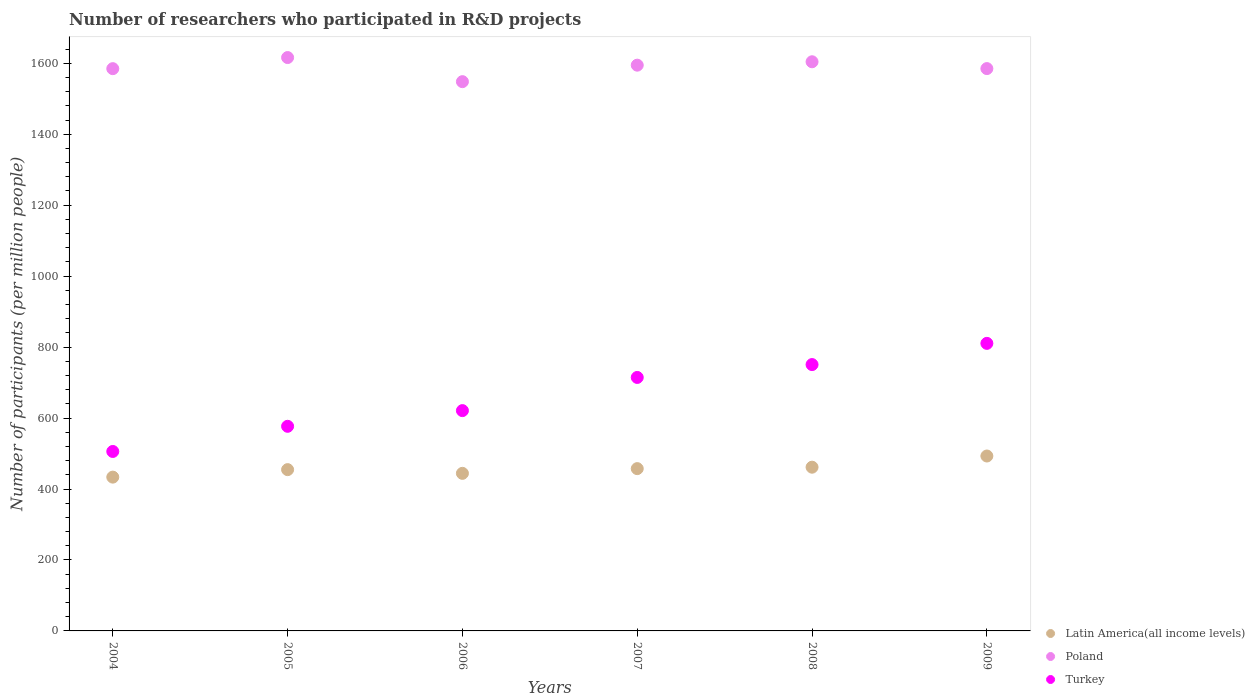How many different coloured dotlines are there?
Keep it short and to the point. 3. What is the number of researchers who participated in R&D projects in Poland in 2006?
Ensure brevity in your answer.  1548.2. Across all years, what is the maximum number of researchers who participated in R&D projects in Latin America(all income levels)?
Keep it short and to the point. 493.02. Across all years, what is the minimum number of researchers who participated in R&D projects in Poland?
Provide a succinct answer. 1548.2. What is the total number of researchers who participated in R&D projects in Turkey in the graph?
Ensure brevity in your answer.  3979.3. What is the difference between the number of researchers who participated in R&D projects in Latin America(all income levels) in 2008 and that in 2009?
Provide a succinct answer. -31.52. What is the difference between the number of researchers who participated in R&D projects in Turkey in 2006 and the number of researchers who participated in R&D projects in Latin America(all income levels) in 2007?
Make the answer very short. 163.5. What is the average number of researchers who participated in R&D projects in Poland per year?
Make the answer very short. 1588.85. In the year 2009, what is the difference between the number of researchers who participated in R&D projects in Poland and number of researchers who participated in R&D projects in Turkey?
Give a very brief answer. 774.51. In how many years, is the number of researchers who participated in R&D projects in Latin America(all income levels) greater than 400?
Make the answer very short. 6. What is the ratio of the number of researchers who participated in R&D projects in Latin America(all income levels) in 2004 to that in 2005?
Offer a terse response. 0.95. Is the number of researchers who participated in R&D projects in Latin America(all income levels) in 2006 less than that in 2009?
Your answer should be compact. Yes. What is the difference between the highest and the second highest number of researchers who participated in R&D projects in Poland?
Keep it short and to the point. 11.88. What is the difference between the highest and the lowest number of researchers who participated in R&D projects in Turkey?
Make the answer very short. 304.7. Does the number of researchers who participated in R&D projects in Poland monotonically increase over the years?
Ensure brevity in your answer.  No. Is the number of researchers who participated in R&D projects in Turkey strictly greater than the number of researchers who participated in R&D projects in Poland over the years?
Offer a very short reply. No. Is the number of researchers who participated in R&D projects in Turkey strictly less than the number of researchers who participated in R&D projects in Poland over the years?
Provide a short and direct response. Yes. How many dotlines are there?
Your answer should be very brief. 3. How many years are there in the graph?
Provide a short and direct response. 6. Where does the legend appear in the graph?
Ensure brevity in your answer.  Bottom right. How many legend labels are there?
Make the answer very short. 3. How are the legend labels stacked?
Your answer should be very brief. Vertical. What is the title of the graph?
Your answer should be very brief. Number of researchers who participated in R&D projects. What is the label or title of the X-axis?
Your response must be concise. Years. What is the label or title of the Y-axis?
Your response must be concise. Number of participants (per million people). What is the Number of participants (per million people) in Latin America(all income levels) in 2004?
Offer a very short reply. 433.5. What is the Number of participants (per million people) of Poland in 2004?
Your answer should be compact. 1584.83. What is the Number of participants (per million people) of Turkey in 2004?
Provide a short and direct response. 505.82. What is the Number of participants (per million people) in Latin America(all income levels) in 2005?
Keep it short and to the point. 454.61. What is the Number of participants (per million people) in Poland in 2005?
Provide a short and direct response. 1616.13. What is the Number of participants (per million people) of Turkey in 2005?
Offer a terse response. 576.76. What is the Number of participants (per million people) of Latin America(all income levels) in 2006?
Provide a succinct answer. 444.14. What is the Number of participants (per million people) of Poland in 2006?
Ensure brevity in your answer.  1548.2. What is the Number of participants (per million people) of Turkey in 2006?
Make the answer very short. 620.97. What is the Number of participants (per million people) in Latin America(all income levels) in 2007?
Give a very brief answer. 457.47. What is the Number of participants (per million people) of Poland in 2007?
Provide a short and direct response. 1594.67. What is the Number of participants (per million people) in Turkey in 2007?
Offer a terse response. 714.49. What is the Number of participants (per million people) of Latin America(all income levels) in 2008?
Your answer should be very brief. 461.5. What is the Number of participants (per million people) of Poland in 2008?
Provide a short and direct response. 1604.26. What is the Number of participants (per million people) of Turkey in 2008?
Ensure brevity in your answer.  750.75. What is the Number of participants (per million people) in Latin America(all income levels) in 2009?
Give a very brief answer. 493.02. What is the Number of participants (per million people) of Poland in 2009?
Provide a succinct answer. 1585.02. What is the Number of participants (per million people) in Turkey in 2009?
Your answer should be very brief. 810.52. Across all years, what is the maximum Number of participants (per million people) of Latin America(all income levels)?
Your answer should be compact. 493.02. Across all years, what is the maximum Number of participants (per million people) in Poland?
Ensure brevity in your answer.  1616.13. Across all years, what is the maximum Number of participants (per million people) in Turkey?
Provide a succinct answer. 810.52. Across all years, what is the minimum Number of participants (per million people) of Latin America(all income levels)?
Give a very brief answer. 433.5. Across all years, what is the minimum Number of participants (per million people) in Poland?
Keep it short and to the point. 1548.2. Across all years, what is the minimum Number of participants (per million people) in Turkey?
Offer a very short reply. 505.82. What is the total Number of participants (per million people) of Latin America(all income levels) in the graph?
Provide a short and direct response. 2744.23. What is the total Number of participants (per million people) of Poland in the graph?
Make the answer very short. 9533.11. What is the total Number of participants (per million people) in Turkey in the graph?
Keep it short and to the point. 3979.3. What is the difference between the Number of participants (per million people) of Latin America(all income levels) in 2004 and that in 2005?
Provide a short and direct response. -21.11. What is the difference between the Number of participants (per million people) in Poland in 2004 and that in 2005?
Provide a succinct answer. -31.3. What is the difference between the Number of participants (per million people) in Turkey in 2004 and that in 2005?
Provide a succinct answer. -70.94. What is the difference between the Number of participants (per million people) in Latin America(all income levels) in 2004 and that in 2006?
Offer a terse response. -10.65. What is the difference between the Number of participants (per million people) in Poland in 2004 and that in 2006?
Your answer should be very brief. 36.64. What is the difference between the Number of participants (per million people) of Turkey in 2004 and that in 2006?
Offer a terse response. -115.15. What is the difference between the Number of participants (per million people) of Latin America(all income levels) in 2004 and that in 2007?
Your response must be concise. -23.97. What is the difference between the Number of participants (per million people) of Poland in 2004 and that in 2007?
Provide a succinct answer. -9.84. What is the difference between the Number of participants (per million people) in Turkey in 2004 and that in 2007?
Give a very brief answer. -208.67. What is the difference between the Number of participants (per million people) in Latin America(all income levels) in 2004 and that in 2008?
Provide a succinct answer. -28. What is the difference between the Number of participants (per million people) of Poland in 2004 and that in 2008?
Keep it short and to the point. -19.42. What is the difference between the Number of participants (per million people) of Turkey in 2004 and that in 2008?
Provide a short and direct response. -244.93. What is the difference between the Number of participants (per million people) in Latin America(all income levels) in 2004 and that in 2009?
Give a very brief answer. -59.53. What is the difference between the Number of participants (per million people) in Poland in 2004 and that in 2009?
Give a very brief answer. -0.19. What is the difference between the Number of participants (per million people) of Turkey in 2004 and that in 2009?
Make the answer very short. -304.7. What is the difference between the Number of participants (per million people) in Latin America(all income levels) in 2005 and that in 2006?
Provide a succinct answer. 10.47. What is the difference between the Number of participants (per million people) of Poland in 2005 and that in 2006?
Offer a terse response. 67.94. What is the difference between the Number of participants (per million people) in Turkey in 2005 and that in 2006?
Keep it short and to the point. -44.21. What is the difference between the Number of participants (per million people) of Latin America(all income levels) in 2005 and that in 2007?
Provide a succinct answer. -2.86. What is the difference between the Number of participants (per million people) in Poland in 2005 and that in 2007?
Offer a terse response. 21.47. What is the difference between the Number of participants (per million people) of Turkey in 2005 and that in 2007?
Provide a succinct answer. -137.73. What is the difference between the Number of participants (per million people) in Latin America(all income levels) in 2005 and that in 2008?
Keep it short and to the point. -6.89. What is the difference between the Number of participants (per million people) in Poland in 2005 and that in 2008?
Provide a succinct answer. 11.88. What is the difference between the Number of participants (per million people) in Turkey in 2005 and that in 2008?
Keep it short and to the point. -173.99. What is the difference between the Number of participants (per million people) in Latin America(all income levels) in 2005 and that in 2009?
Offer a very short reply. -38.41. What is the difference between the Number of participants (per million people) in Poland in 2005 and that in 2009?
Provide a succinct answer. 31.11. What is the difference between the Number of participants (per million people) of Turkey in 2005 and that in 2009?
Your answer should be very brief. -233.76. What is the difference between the Number of participants (per million people) in Latin America(all income levels) in 2006 and that in 2007?
Offer a very short reply. -13.32. What is the difference between the Number of participants (per million people) of Poland in 2006 and that in 2007?
Offer a very short reply. -46.47. What is the difference between the Number of participants (per million people) of Turkey in 2006 and that in 2007?
Give a very brief answer. -93.52. What is the difference between the Number of participants (per million people) of Latin America(all income levels) in 2006 and that in 2008?
Your answer should be compact. -17.35. What is the difference between the Number of participants (per million people) of Poland in 2006 and that in 2008?
Your answer should be compact. -56.06. What is the difference between the Number of participants (per million people) in Turkey in 2006 and that in 2008?
Offer a terse response. -129.78. What is the difference between the Number of participants (per million people) of Latin America(all income levels) in 2006 and that in 2009?
Ensure brevity in your answer.  -48.88. What is the difference between the Number of participants (per million people) of Poland in 2006 and that in 2009?
Ensure brevity in your answer.  -36.83. What is the difference between the Number of participants (per million people) in Turkey in 2006 and that in 2009?
Offer a terse response. -189.55. What is the difference between the Number of participants (per million people) of Latin America(all income levels) in 2007 and that in 2008?
Provide a succinct answer. -4.03. What is the difference between the Number of participants (per million people) in Poland in 2007 and that in 2008?
Ensure brevity in your answer.  -9.59. What is the difference between the Number of participants (per million people) of Turkey in 2007 and that in 2008?
Make the answer very short. -36.26. What is the difference between the Number of participants (per million people) in Latin America(all income levels) in 2007 and that in 2009?
Make the answer very short. -35.56. What is the difference between the Number of participants (per million people) of Poland in 2007 and that in 2009?
Your response must be concise. 9.65. What is the difference between the Number of participants (per million people) in Turkey in 2007 and that in 2009?
Keep it short and to the point. -96.03. What is the difference between the Number of participants (per million people) of Latin America(all income levels) in 2008 and that in 2009?
Make the answer very short. -31.52. What is the difference between the Number of participants (per million people) in Poland in 2008 and that in 2009?
Your answer should be compact. 19.23. What is the difference between the Number of participants (per million people) in Turkey in 2008 and that in 2009?
Offer a very short reply. -59.77. What is the difference between the Number of participants (per million people) in Latin America(all income levels) in 2004 and the Number of participants (per million people) in Poland in 2005?
Ensure brevity in your answer.  -1182.64. What is the difference between the Number of participants (per million people) in Latin America(all income levels) in 2004 and the Number of participants (per million people) in Turkey in 2005?
Provide a succinct answer. -143.26. What is the difference between the Number of participants (per million people) of Poland in 2004 and the Number of participants (per million people) of Turkey in 2005?
Your answer should be compact. 1008.08. What is the difference between the Number of participants (per million people) in Latin America(all income levels) in 2004 and the Number of participants (per million people) in Poland in 2006?
Ensure brevity in your answer.  -1114.7. What is the difference between the Number of participants (per million people) in Latin America(all income levels) in 2004 and the Number of participants (per million people) in Turkey in 2006?
Make the answer very short. -187.47. What is the difference between the Number of participants (per million people) in Poland in 2004 and the Number of participants (per million people) in Turkey in 2006?
Your answer should be very brief. 963.86. What is the difference between the Number of participants (per million people) of Latin America(all income levels) in 2004 and the Number of participants (per million people) of Poland in 2007?
Keep it short and to the point. -1161.17. What is the difference between the Number of participants (per million people) of Latin America(all income levels) in 2004 and the Number of participants (per million people) of Turkey in 2007?
Offer a very short reply. -280.99. What is the difference between the Number of participants (per million people) in Poland in 2004 and the Number of participants (per million people) in Turkey in 2007?
Your answer should be compact. 870.35. What is the difference between the Number of participants (per million people) in Latin America(all income levels) in 2004 and the Number of participants (per million people) in Poland in 2008?
Give a very brief answer. -1170.76. What is the difference between the Number of participants (per million people) in Latin America(all income levels) in 2004 and the Number of participants (per million people) in Turkey in 2008?
Provide a short and direct response. -317.25. What is the difference between the Number of participants (per million people) of Poland in 2004 and the Number of participants (per million people) of Turkey in 2008?
Provide a succinct answer. 834.09. What is the difference between the Number of participants (per million people) in Latin America(all income levels) in 2004 and the Number of participants (per million people) in Poland in 2009?
Offer a very short reply. -1151.53. What is the difference between the Number of participants (per million people) of Latin America(all income levels) in 2004 and the Number of participants (per million people) of Turkey in 2009?
Keep it short and to the point. -377.02. What is the difference between the Number of participants (per million people) of Poland in 2004 and the Number of participants (per million people) of Turkey in 2009?
Make the answer very short. 774.32. What is the difference between the Number of participants (per million people) of Latin America(all income levels) in 2005 and the Number of participants (per million people) of Poland in 2006?
Provide a succinct answer. -1093.59. What is the difference between the Number of participants (per million people) of Latin America(all income levels) in 2005 and the Number of participants (per million people) of Turkey in 2006?
Offer a very short reply. -166.36. What is the difference between the Number of participants (per million people) in Poland in 2005 and the Number of participants (per million people) in Turkey in 2006?
Offer a terse response. 995.17. What is the difference between the Number of participants (per million people) in Latin America(all income levels) in 2005 and the Number of participants (per million people) in Poland in 2007?
Your answer should be compact. -1140.06. What is the difference between the Number of participants (per million people) of Latin America(all income levels) in 2005 and the Number of participants (per million people) of Turkey in 2007?
Offer a terse response. -259.88. What is the difference between the Number of participants (per million people) in Poland in 2005 and the Number of participants (per million people) in Turkey in 2007?
Your answer should be very brief. 901.65. What is the difference between the Number of participants (per million people) of Latin America(all income levels) in 2005 and the Number of participants (per million people) of Poland in 2008?
Provide a short and direct response. -1149.65. What is the difference between the Number of participants (per million people) of Latin America(all income levels) in 2005 and the Number of participants (per million people) of Turkey in 2008?
Your answer should be compact. -296.14. What is the difference between the Number of participants (per million people) of Poland in 2005 and the Number of participants (per million people) of Turkey in 2008?
Provide a short and direct response. 865.39. What is the difference between the Number of participants (per million people) of Latin America(all income levels) in 2005 and the Number of participants (per million people) of Poland in 2009?
Provide a short and direct response. -1130.41. What is the difference between the Number of participants (per million people) of Latin America(all income levels) in 2005 and the Number of participants (per million people) of Turkey in 2009?
Your response must be concise. -355.91. What is the difference between the Number of participants (per million people) in Poland in 2005 and the Number of participants (per million people) in Turkey in 2009?
Your response must be concise. 805.62. What is the difference between the Number of participants (per million people) of Latin America(all income levels) in 2006 and the Number of participants (per million people) of Poland in 2007?
Give a very brief answer. -1150.52. What is the difference between the Number of participants (per million people) in Latin America(all income levels) in 2006 and the Number of participants (per million people) in Turkey in 2007?
Give a very brief answer. -270.34. What is the difference between the Number of participants (per million people) of Poland in 2006 and the Number of participants (per million people) of Turkey in 2007?
Offer a terse response. 833.71. What is the difference between the Number of participants (per million people) of Latin America(all income levels) in 2006 and the Number of participants (per million people) of Poland in 2008?
Offer a terse response. -1160.11. What is the difference between the Number of participants (per million people) of Latin America(all income levels) in 2006 and the Number of participants (per million people) of Turkey in 2008?
Provide a succinct answer. -306.6. What is the difference between the Number of participants (per million people) of Poland in 2006 and the Number of participants (per million people) of Turkey in 2008?
Offer a terse response. 797.45. What is the difference between the Number of participants (per million people) of Latin America(all income levels) in 2006 and the Number of participants (per million people) of Poland in 2009?
Your answer should be very brief. -1140.88. What is the difference between the Number of participants (per million people) in Latin America(all income levels) in 2006 and the Number of participants (per million people) in Turkey in 2009?
Make the answer very short. -366.37. What is the difference between the Number of participants (per million people) of Poland in 2006 and the Number of participants (per million people) of Turkey in 2009?
Offer a terse response. 737.68. What is the difference between the Number of participants (per million people) of Latin America(all income levels) in 2007 and the Number of participants (per million people) of Poland in 2008?
Make the answer very short. -1146.79. What is the difference between the Number of participants (per million people) of Latin America(all income levels) in 2007 and the Number of participants (per million people) of Turkey in 2008?
Keep it short and to the point. -293.28. What is the difference between the Number of participants (per million people) of Poland in 2007 and the Number of participants (per million people) of Turkey in 2008?
Your answer should be compact. 843.92. What is the difference between the Number of participants (per million people) of Latin America(all income levels) in 2007 and the Number of participants (per million people) of Poland in 2009?
Give a very brief answer. -1127.56. What is the difference between the Number of participants (per million people) in Latin America(all income levels) in 2007 and the Number of participants (per million people) in Turkey in 2009?
Make the answer very short. -353.05. What is the difference between the Number of participants (per million people) of Poland in 2007 and the Number of participants (per million people) of Turkey in 2009?
Your answer should be very brief. 784.15. What is the difference between the Number of participants (per million people) in Latin America(all income levels) in 2008 and the Number of participants (per million people) in Poland in 2009?
Your answer should be very brief. -1123.53. What is the difference between the Number of participants (per million people) in Latin America(all income levels) in 2008 and the Number of participants (per million people) in Turkey in 2009?
Make the answer very short. -349.02. What is the difference between the Number of participants (per million people) in Poland in 2008 and the Number of participants (per million people) in Turkey in 2009?
Make the answer very short. 793.74. What is the average Number of participants (per million people) in Latin America(all income levels) per year?
Keep it short and to the point. 457.37. What is the average Number of participants (per million people) in Poland per year?
Offer a very short reply. 1588.85. What is the average Number of participants (per million people) in Turkey per year?
Make the answer very short. 663.22. In the year 2004, what is the difference between the Number of participants (per million people) in Latin America(all income levels) and Number of participants (per million people) in Poland?
Provide a short and direct response. -1151.34. In the year 2004, what is the difference between the Number of participants (per million people) in Latin America(all income levels) and Number of participants (per million people) in Turkey?
Give a very brief answer. -72.32. In the year 2004, what is the difference between the Number of participants (per million people) of Poland and Number of participants (per million people) of Turkey?
Provide a succinct answer. 1079.01. In the year 2005, what is the difference between the Number of participants (per million people) in Latin America(all income levels) and Number of participants (per million people) in Poland?
Offer a terse response. -1161.52. In the year 2005, what is the difference between the Number of participants (per million people) in Latin America(all income levels) and Number of participants (per million people) in Turkey?
Offer a terse response. -122.15. In the year 2005, what is the difference between the Number of participants (per million people) in Poland and Number of participants (per million people) in Turkey?
Offer a very short reply. 1039.38. In the year 2006, what is the difference between the Number of participants (per million people) of Latin America(all income levels) and Number of participants (per million people) of Poland?
Keep it short and to the point. -1104.05. In the year 2006, what is the difference between the Number of participants (per million people) in Latin America(all income levels) and Number of participants (per million people) in Turkey?
Make the answer very short. -176.82. In the year 2006, what is the difference between the Number of participants (per million people) of Poland and Number of participants (per million people) of Turkey?
Ensure brevity in your answer.  927.23. In the year 2007, what is the difference between the Number of participants (per million people) of Latin America(all income levels) and Number of participants (per million people) of Poland?
Provide a short and direct response. -1137.2. In the year 2007, what is the difference between the Number of participants (per million people) of Latin America(all income levels) and Number of participants (per million people) of Turkey?
Make the answer very short. -257.02. In the year 2007, what is the difference between the Number of participants (per million people) in Poland and Number of participants (per million people) in Turkey?
Your answer should be compact. 880.18. In the year 2008, what is the difference between the Number of participants (per million people) of Latin America(all income levels) and Number of participants (per million people) of Poland?
Provide a short and direct response. -1142.76. In the year 2008, what is the difference between the Number of participants (per million people) in Latin America(all income levels) and Number of participants (per million people) in Turkey?
Ensure brevity in your answer.  -289.25. In the year 2008, what is the difference between the Number of participants (per million people) of Poland and Number of participants (per million people) of Turkey?
Provide a succinct answer. 853.51. In the year 2009, what is the difference between the Number of participants (per million people) of Latin America(all income levels) and Number of participants (per million people) of Poland?
Offer a terse response. -1092. In the year 2009, what is the difference between the Number of participants (per million people) of Latin America(all income levels) and Number of participants (per million people) of Turkey?
Ensure brevity in your answer.  -317.5. In the year 2009, what is the difference between the Number of participants (per million people) in Poland and Number of participants (per million people) in Turkey?
Make the answer very short. 774.51. What is the ratio of the Number of participants (per million people) in Latin America(all income levels) in 2004 to that in 2005?
Your answer should be very brief. 0.95. What is the ratio of the Number of participants (per million people) in Poland in 2004 to that in 2005?
Offer a very short reply. 0.98. What is the ratio of the Number of participants (per million people) in Turkey in 2004 to that in 2005?
Your response must be concise. 0.88. What is the ratio of the Number of participants (per million people) in Poland in 2004 to that in 2006?
Keep it short and to the point. 1.02. What is the ratio of the Number of participants (per million people) of Turkey in 2004 to that in 2006?
Provide a succinct answer. 0.81. What is the ratio of the Number of participants (per million people) in Latin America(all income levels) in 2004 to that in 2007?
Offer a very short reply. 0.95. What is the ratio of the Number of participants (per million people) of Turkey in 2004 to that in 2007?
Give a very brief answer. 0.71. What is the ratio of the Number of participants (per million people) in Latin America(all income levels) in 2004 to that in 2008?
Your answer should be very brief. 0.94. What is the ratio of the Number of participants (per million people) in Poland in 2004 to that in 2008?
Give a very brief answer. 0.99. What is the ratio of the Number of participants (per million people) in Turkey in 2004 to that in 2008?
Your response must be concise. 0.67. What is the ratio of the Number of participants (per million people) in Latin America(all income levels) in 2004 to that in 2009?
Provide a succinct answer. 0.88. What is the ratio of the Number of participants (per million people) of Poland in 2004 to that in 2009?
Make the answer very short. 1. What is the ratio of the Number of participants (per million people) in Turkey in 2004 to that in 2009?
Give a very brief answer. 0.62. What is the ratio of the Number of participants (per million people) of Latin America(all income levels) in 2005 to that in 2006?
Your answer should be very brief. 1.02. What is the ratio of the Number of participants (per million people) of Poland in 2005 to that in 2006?
Offer a very short reply. 1.04. What is the ratio of the Number of participants (per million people) in Turkey in 2005 to that in 2006?
Your answer should be very brief. 0.93. What is the ratio of the Number of participants (per million people) of Poland in 2005 to that in 2007?
Your response must be concise. 1.01. What is the ratio of the Number of participants (per million people) in Turkey in 2005 to that in 2007?
Your answer should be compact. 0.81. What is the ratio of the Number of participants (per million people) of Latin America(all income levels) in 2005 to that in 2008?
Provide a succinct answer. 0.99. What is the ratio of the Number of participants (per million people) of Poland in 2005 to that in 2008?
Your answer should be compact. 1.01. What is the ratio of the Number of participants (per million people) in Turkey in 2005 to that in 2008?
Provide a succinct answer. 0.77. What is the ratio of the Number of participants (per million people) of Latin America(all income levels) in 2005 to that in 2009?
Offer a very short reply. 0.92. What is the ratio of the Number of participants (per million people) of Poland in 2005 to that in 2009?
Your response must be concise. 1.02. What is the ratio of the Number of participants (per million people) in Turkey in 2005 to that in 2009?
Your answer should be compact. 0.71. What is the ratio of the Number of participants (per million people) of Latin America(all income levels) in 2006 to that in 2007?
Offer a very short reply. 0.97. What is the ratio of the Number of participants (per million people) in Poland in 2006 to that in 2007?
Your answer should be compact. 0.97. What is the ratio of the Number of participants (per million people) of Turkey in 2006 to that in 2007?
Your answer should be very brief. 0.87. What is the ratio of the Number of participants (per million people) of Latin America(all income levels) in 2006 to that in 2008?
Your answer should be very brief. 0.96. What is the ratio of the Number of participants (per million people) in Poland in 2006 to that in 2008?
Keep it short and to the point. 0.97. What is the ratio of the Number of participants (per million people) in Turkey in 2006 to that in 2008?
Your response must be concise. 0.83. What is the ratio of the Number of participants (per million people) of Latin America(all income levels) in 2006 to that in 2009?
Provide a short and direct response. 0.9. What is the ratio of the Number of participants (per million people) in Poland in 2006 to that in 2009?
Your answer should be compact. 0.98. What is the ratio of the Number of participants (per million people) in Turkey in 2006 to that in 2009?
Offer a very short reply. 0.77. What is the ratio of the Number of participants (per million people) in Poland in 2007 to that in 2008?
Offer a terse response. 0.99. What is the ratio of the Number of participants (per million people) in Turkey in 2007 to that in 2008?
Your answer should be compact. 0.95. What is the ratio of the Number of participants (per million people) in Latin America(all income levels) in 2007 to that in 2009?
Provide a succinct answer. 0.93. What is the ratio of the Number of participants (per million people) in Poland in 2007 to that in 2009?
Your answer should be compact. 1.01. What is the ratio of the Number of participants (per million people) in Turkey in 2007 to that in 2009?
Your response must be concise. 0.88. What is the ratio of the Number of participants (per million people) in Latin America(all income levels) in 2008 to that in 2009?
Your answer should be compact. 0.94. What is the ratio of the Number of participants (per million people) in Poland in 2008 to that in 2009?
Keep it short and to the point. 1.01. What is the ratio of the Number of participants (per million people) in Turkey in 2008 to that in 2009?
Provide a short and direct response. 0.93. What is the difference between the highest and the second highest Number of participants (per million people) of Latin America(all income levels)?
Give a very brief answer. 31.52. What is the difference between the highest and the second highest Number of participants (per million people) in Poland?
Your answer should be compact. 11.88. What is the difference between the highest and the second highest Number of participants (per million people) of Turkey?
Your response must be concise. 59.77. What is the difference between the highest and the lowest Number of participants (per million people) in Latin America(all income levels)?
Your answer should be very brief. 59.53. What is the difference between the highest and the lowest Number of participants (per million people) in Poland?
Give a very brief answer. 67.94. What is the difference between the highest and the lowest Number of participants (per million people) in Turkey?
Give a very brief answer. 304.7. 